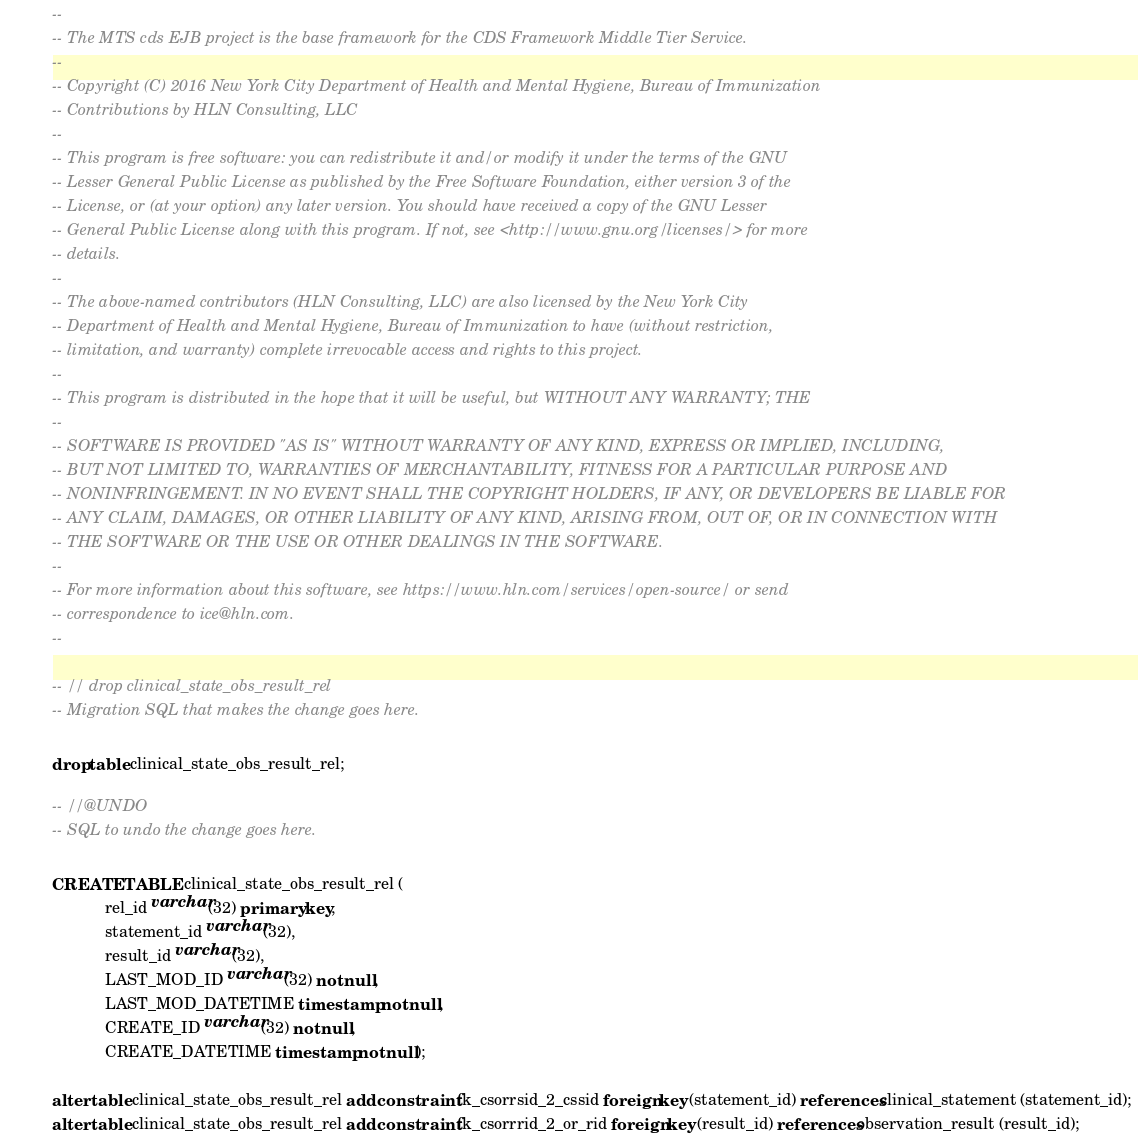Convert code to text. <code><loc_0><loc_0><loc_500><loc_500><_SQL_>--
-- The MTS cds EJB project is the base framework for the CDS Framework Middle Tier Service.
--
-- Copyright (C) 2016 New York City Department of Health and Mental Hygiene, Bureau of Immunization
-- Contributions by HLN Consulting, LLC
--
-- This program is free software: you can redistribute it and/or modify it under the terms of the GNU
-- Lesser General Public License as published by the Free Software Foundation, either version 3 of the
-- License, or (at your option) any later version. You should have received a copy of the GNU Lesser
-- General Public License along with this program. If not, see <http://www.gnu.org/licenses/> for more
-- details.
--
-- The above-named contributors (HLN Consulting, LLC) are also licensed by the New York City
-- Department of Health and Mental Hygiene, Bureau of Immunization to have (without restriction,
-- limitation, and warranty) complete irrevocable access and rights to this project.
--
-- This program is distributed in the hope that it will be useful, but WITHOUT ANY WARRANTY; THE
--
-- SOFTWARE IS PROVIDED "AS IS" WITHOUT WARRANTY OF ANY KIND, EXPRESS OR IMPLIED, INCLUDING,
-- BUT NOT LIMITED TO, WARRANTIES OF MERCHANTABILITY, FITNESS FOR A PARTICULAR PURPOSE AND
-- NONINFRINGEMENT. IN NO EVENT SHALL THE COPYRIGHT HOLDERS, IF ANY, OR DEVELOPERS BE LIABLE FOR
-- ANY CLAIM, DAMAGES, OR OTHER LIABILITY OF ANY KIND, ARISING FROM, OUT OF, OR IN CONNECTION WITH
-- THE SOFTWARE OR THE USE OR OTHER DEALINGS IN THE SOFTWARE.
--
-- For more information about this software, see https://www.hln.com/services/open-source/ or send
-- correspondence to ice@hln.com.
--

-- // drop clinical_state_obs_result_rel
-- Migration SQL that makes the change goes here.

drop table clinical_state_obs_result_rel;

-- //@UNDO
-- SQL to undo the change goes here.

CREATE TABLE clinical_state_obs_result_rel (
            rel_id varchar(32) primary key,
            statement_id varchar(32),
            result_id varchar(32),
            LAST_MOD_ID varchar(32) not null,
            LAST_MOD_DATETIME timestamp not null,
            CREATE_ID varchar(32) not null,
            CREATE_DATETIME timestamp not null);

alter table clinical_state_obs_result_rel add constraint fk_csorrsid_2_cssid foreign key (statement_id) references clinical_statement (statement_id);
alter table clinical_state_obs_result_rel add constraint fk_csorrrid_2_or_rid foreign key (result_id) references observation_result (result_id);
</code> 